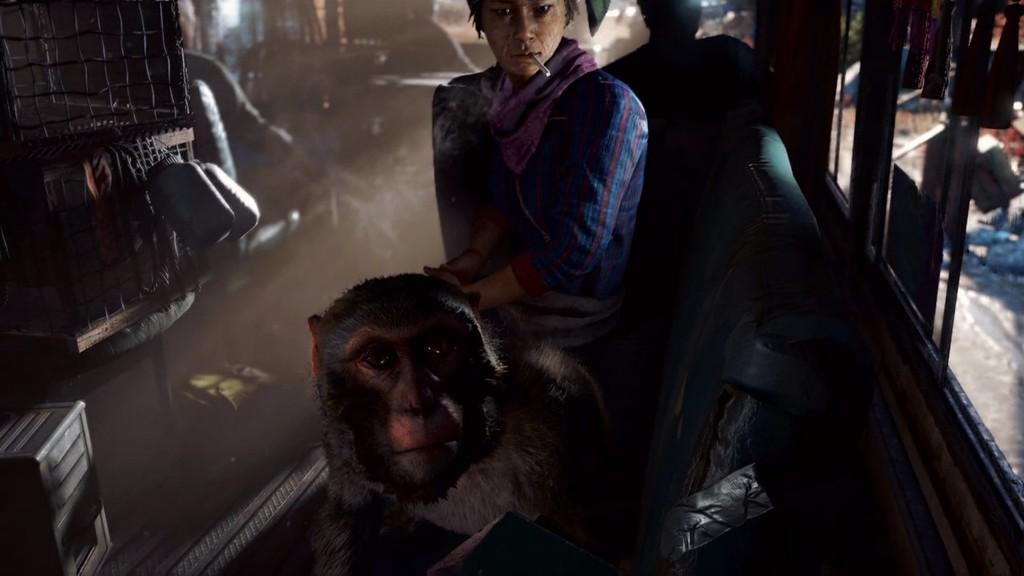Describe this image in one or two sentences. In this picture there is a man and a monkey sitting on the chair. He is having a cigarette in his mouth. There is a bottle and few people sitting at the background. 